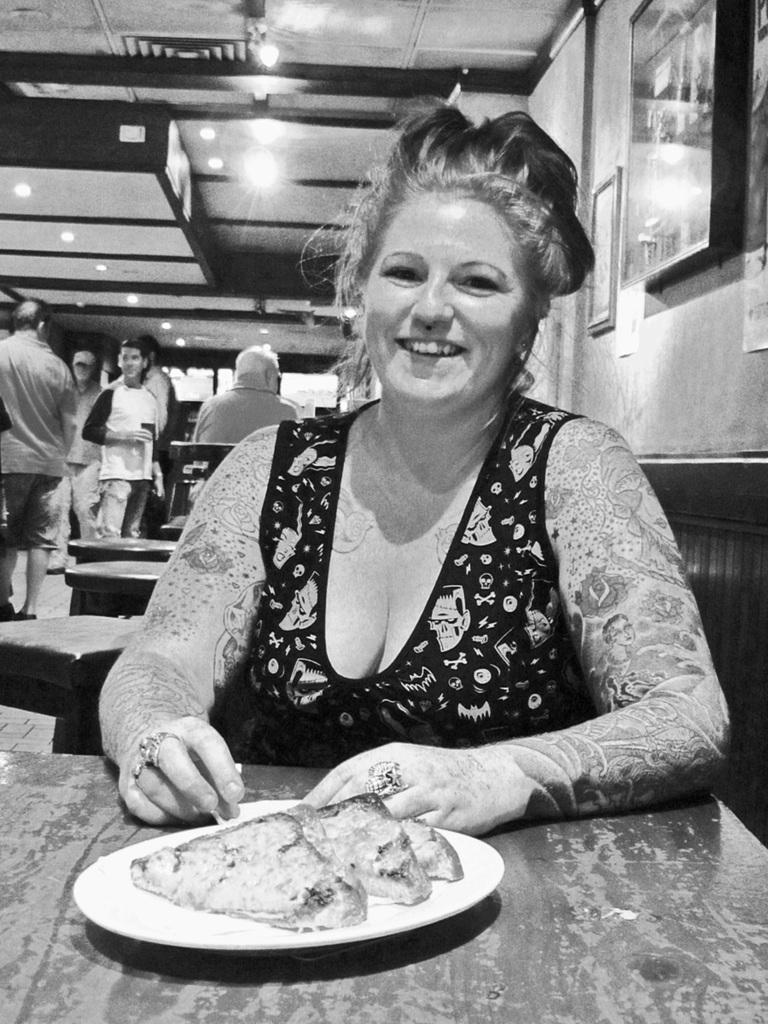Could you give a brief overview of what you see in this image? In this picture we can see a woman is sitting in front of a table, there is a plate on the table, we can see some food in this plate, in the background there are some people standing, on the right side there is a wall, we can see a photo frame on the wall, there are some lights at the top of the picture. 